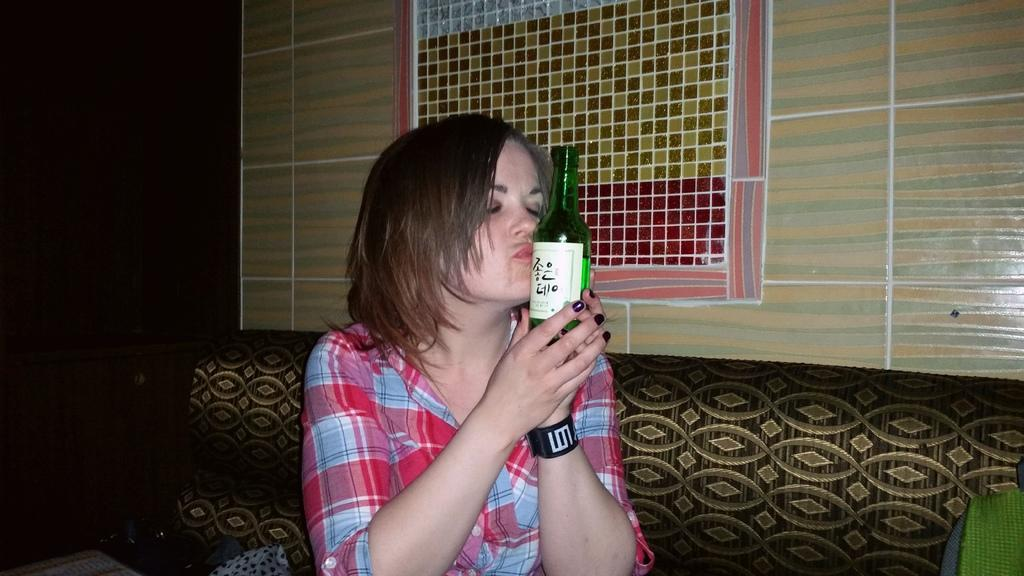Who is present in the image? There is a woman in the image. What is the woman holding in the image? The woman is holding a bottle. What can be seen in the background of the image? There is a sofa, a wall, and a window in the background of the image. What type of berry can be seen growing on the wall in the image? There is no berry growing on the wall in the image; the wall is a part of the background and does not have any plants or berries. 